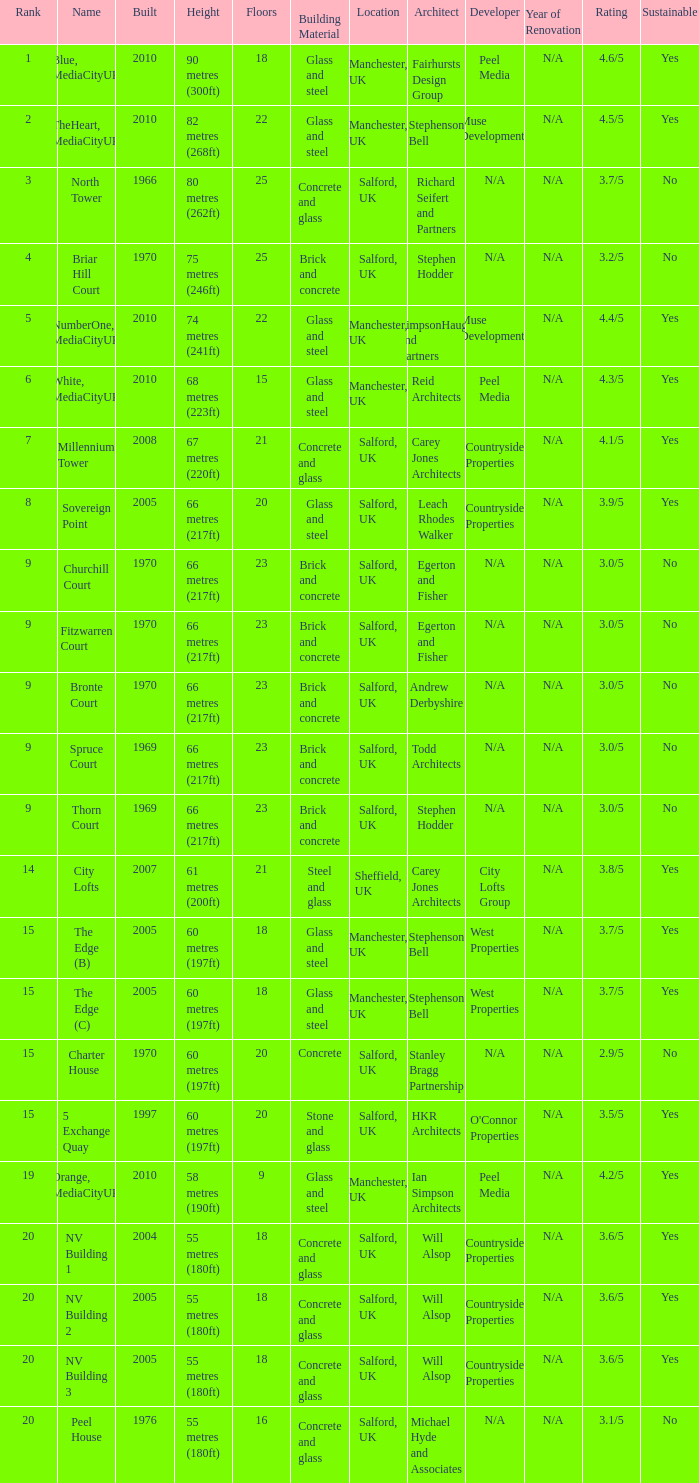What is the total number of Built, when Floors is less than 22, when Rank is less than 8, and when Name is White, Mediacityuk? 1.0. 